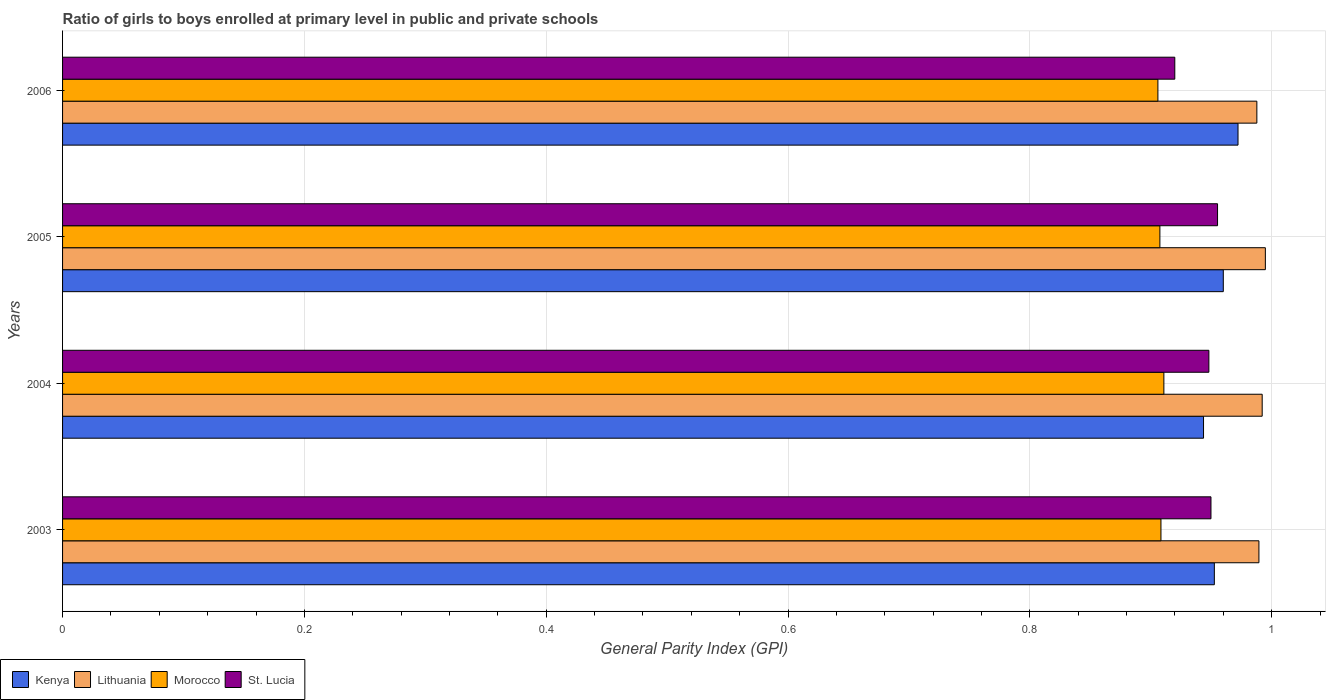How many groups of bars are there?
Provide a short and direct response. 4. Are the number of bars per tick equal to the number of legend labels?
Offer a terse response. Yes. What is the general parity index in St. Lucia in 2004?
Ensure brevity in your answer.  0.95. Across all years, what is the maximum general parity index in Kenya?
Your response must be concise. 0.97. Across all years, what is the minimum general parity index in Lithuania?
Your answer should be very brief. 0.99. What is the total general parity index in Kenya in the graph?
Your answer should be very brief. 3.83. What is the difference between the general parity index in Lithuania in 2003 and that in 2006?
Your answer should be compact. 0. What is the difference between the general parity index in St. Lucia in 2004 and the general parity index in Kenya in 2005?
Offer a very short reply. -0.01. What is the average general parity index in Morocco per year?
Ensure brevity in your answer.  0.91. In the year 2005, what is the difference between the general parity index in St. Lucia and general parity index in Lithuania?
Provide a short and direct response. -0.04. In how many years, is the general parity index in St. Lucia greater than 0.16 ?
Your answer should be compact. 4. What is the ratio of the general parity index in Kenya in 2004 to that in 2005?
Your answer should be very brief. 0.98. Is the difference between the general parity index in St. Lucia in 2004 and 2006 greater than the difference between the general parity index in Lithuania in 2004 and 2006?
Offer a terse response. Yes. What is the difference between the highest and the second highest general parity index in Lithuania?
Ensure brevity in your answer.  0. What is the difference between the highest and the lowest general parity index in Kenya?
Ensure brevity in your answer.  0.03. In how many years, is the general parity index in St. Lucia greater than the average general parity index in St. Lucia taken over all years?
Your response must be concise. 3. Is the sum of the general parity index in St. Lucia in 2003 and 2006 greater than the maximum general parity index in Lithuania across all years?
Your answer should be very brief. Yes. Is it the case that in every year, the sum of the general parity index in Kenya and general parity index in Lithuania is greater than the sum of general parity index in Morocco and general parity index in St. Lucia?
Provide a short and direct response. No. What does the 2nd bar from the top in 2003 represents?
Offer a very short reply. Morocco. What does the 2nd bar from the bottom in 2003 represents?
Offer a very short reply. Lithuania. How many bars are there?
Keep it short and to the point. 16. What is the difference between two consecutive major ticks on the X-axis?
Make the answer very short. 0.2. Are the values on the major ticks of X-axis written in scientific E-notation?
Keep it short and to the point. No. Does the graph contain grids?
Your answer should be very brief. Yes. Where does the legend appear in the graph?
Ensure brevity in your answer.  Bottom left. How many legend labels are there?
Offer a very short reply. 4. How are the legend labels stacked?
Make the answer very short. Horizontal. What is the title of the graph?
Make the answer very short. Ratio of girls to boys enrolled at primary level in public and private schools. What is the label or title of the X-axis?
Offer a very short reply. General Parity Index (GPI). What is the General Parity Index (GPI) in Kenya in 2003?
Provide a short and direct response. 0.95. What is the General Parity Index (GPI) in Lithuania in 2003?
Provide a short and direct response. 0.99. What is the General Parity Index (GPI) of Morocco in 2003?
Your response must be concise. 0.91. What is the General Parity Index (GPI) in St. Lucia in 2003?
Keep it short and to the point. 0.95. What is the General Parity Index (GPI) in Kenya in 2004?
Your answer should be very brief. 0.94. What is the General Parity Index (GPI) in Lithuania in 2004?
Ensure brevity in your answer.  0.99. What is the General Parity Index (GPI) of Morocco in 2004?
Give a very brief answer. 0.91. What is the General Parity Index (GPI) of St. Lucia in 2004?
Your response must be concise. 0.95. What is the General Parity Index (GPI) of Kenya in 2005?
Provide a short and direct response. 0.96. What is the General Parity Index (GPI) in Lithuania in 2005?
Make the answer very short. 0.99. What is the General Parity Index (GPI) of Morocco in 2005?
Provide a succinct answer. 0.91. What is the General Parity Index (GPI) of St. Lucia in 2005?
Offer a very short reply. 0.96. What is the General Parity Index (GPI) of Kenya in 2006?
Make the answer very short. 0.97. What is the General Parity Index (GPI) in Lithuania in 2006?
Offer a very short reply. 0.99. What is the General Parity Index (GPI) of Morocco in 2006?
Ensure brevity in your answer.  0.91. What is the General Parity Index (GPI) in St. Lucia in 2006?
Your answer should be very brief. 0.92. Across all years, what is the maximum General Parity Index (GPI) in Kenya?
Keep it short and to the point. 0.97. Across all years, what is the maximum General Parity Index (GPI) in Lithuania?
Ensure brevity in your answer.  0.99. Across all years, what is the maximum General Parity Index (GPI) of Morocco?
Your answer should be compact. 0.91. Across all years, what is the maximum General Parity Index (GPI) in St. Lucia?
Offer a very short reply. 0.96. Across all years, what is the minimum General Parity Index (GPI) of Kenya?
Keep it short and to the point. 0.94. Across all years, what is the minimum General Parity Index (GPI) in Lithuania?
Offer a very short reply. 0.99. Across all years, what is the minimum General Parity Index (GPI) in Morocco?
Provide a succinct answer. 0.91. Across all years, what is the minimum General Parity Index (GPI) in St. Lucia?
Your answer should be very brief. 0.92. What is the total General Parity Index (GPI) in Kenya in the graph?
Make the answer very short. 3.83. What is the total General Parity Index (GPI) of Lithuania in the graph?
Your answer should be very brief. 3.96. What is the total General Parity Index (GPI) of Morocco in the graph?
Ensure brevity in your answer.  3.63. What is the total General Parity Index (GPI) of St. Lucia in the graph?
Offer a terse response. 3.77. What is the difference between the General Parity Index (GPI) in Kenya in 2003 and that in 2004?
Offer a very short reply. 0.01. What is the difference between the General Parity Index (GPI) in Lithuania in 2003 and that in 2004?
Your response must be concise. -0. What is the difference between the General Parity Index (GPI) in Morocco in 2003 and that in 2004?
Make the answer very short. -0. What is the difference between the General Parity Index (GPI) in St. Lucia in 2003 and that in 2004?
Offer a very short reply. 0. What is the difference between the General Parity Index (GPI) in Kenya in 2003 and that in 2005?
Your answer should be compact. -0.01. What is the difference between the General Parity Index (GPI) of Lithuania in 2003 and that in 2005?
Your response must be concise. -0.01. What is the difference between the General Parity Index (GPI) of Morocco in 2003 and that in 2005?
Keep it short and to the point. 0. What is the difference between the General Parity Index (GPI) of St. Lucia in 2003 and that in 2005?
Ensure brevity in your answer.  -0.01. What is the difference between the General Parity Index (GPI) in Kenya in 2003 and that in 2006?
Your answer should be very brief. -0.02. What is the difference between the General Parity Index (GPI) of Lithuania in 2003 and that in 2006?
Offer a terse response. 0. What is the difference between the General Parity Index (GPI) in Morocco in 2003 and that in 2006?
Your response must be concise. 0. What is the difference between the General Parity Index (GPI) of St. Lucia in 2003 and that in 2006?
Keep it short and to the point. 0.03. What is the difference between the General Parity Index (GPI) in Kenya in 2004 and that in 2005?
Your response must be concise. -0.02. What is the difference between the General Parity Index (GPI) of Lithuania in 2004 and that in 2005?
Offer a very short reply. -0. What is the difference between the General Parity Index (GPI) of Morocco in 2004 and that in 2005?
Make the answer very short. 0. What is the difference between the General Parity Index (GPI) of St. Lucia in 2004 and that in 2005?
Provide a succinct answer. -0.01. What is the difference between the General Parity Index (GPI) in Kenya in 2004 and that in 2006?
Your answer should be compact. -0.03. What is the difference between the General Parity Index (GPI) in Lithuania in 2004 and that in 2006?
Ensure brevity in your answer.  0. What is the difference between the General Parity Index (GPI) of Morocco in 2004 and that in 2006?
Your answer should be very brief. 0. What is the difference between the General Parity Index (GPI) in St. Lucia in 2004 and that in 2006?
Your answer should be very brief. 0.03. What is the difference between the General Parity Index (GPI) in Kenya in 2005 and that in 2006?
Your response must be concise. -0.01. What is the difference between the General Parity Index (GPI) of Lithuania in 2005 and that in 2006?
Keep it short and to the point. 0.01. What is the difference between the General Parity Index (GPI) in Morocco in 2005 and that in 2006?
Provide a succinct answer. 0. What is the difference between the General Parity Index (GPI) in St. Lucia in 2005 and that in 2006?
Ensure brevity in your answer.  0.04. What is the difference between the General Parity Index (GPI) of Kenya in 2003 and the General Parity Index (GPI) of Lithuania in 2004?
Provide a succinct answer. -0.04. What is the difference between the General Parity Index (GPI) of Kenya in 2003 and the General Parity Index (GPI) of Morocco in 2004?
Your answer should be compact. 0.04. What is the difference between the General Parity Index (GPI) of Kenya in 2003 and the General Parity Index (GPI) of St. Lucia in 2004?
Your answer should be compact. 0. What is the difference between the General Parity Index (GPI) of Lithuania in 2003 and the General Parity Index (GPI) of Morocco in 2004?
Keep it short and to the point. 0.08. What is the difference between the General Parity Index (GPI) of Lithuania in 2003 and the General Parity Index (GPI) of St. Lucia in 2004?
Keep it short and to the point. 0.04. What is the difference between the General Parity Index (GPI) in Morocco in 2003 and the General Parity Index (GPI) in St. Lucia in 2004?
Your answer should be compact. -0.04. What is the difference between the General Parity Index (GPI) in Kenya in 2003 and the General Parity Index (GPI) in Lithuania in 2005?
Keep it short and to the point. -0.04. What is the difference between the General Parity Index (GPI) of Kenya in 2003 and the General Parity Index (GPI) of Morocco in 2005?
Provide a short and direct response. 0.04. What is the difference between the General Parity Index (GPI) in Kenya in 2003 and the General Parity Index (GPI) in St. Lucia in 2005?
Your response must be concise. -0. What is the difference between the General Parity Index (GPI) in Lithuania in 2003 and the General Parity Index (GPI) in Morocco in 2005?
Keep it short and to the point. 0.08. What is the difference between the General Parity Index (GPI) in Lithuania in 2003 and the General Parity Index (GPI) in St. Lucia in 2005?
Provide a succinct answer. 0.03. What is the difference between the General Parity Index (GPI) in Morocco in 2003 and the General Parity Index (GPI) in St. Lucia in 2005?
Your answer should be compact. -0.05. What is the difference between the General Parity Index (GPI) in Kenya in 2003 and the General Parity Index (GPI) in Lithuania in 2006?
Your answer should be compact. -0.04. What is the difference between the General Parity Index (GPI) in Kenya in 2003 and the General Parity Index (GPI) in Morocco in 2006?
Your answer should be very brief. 0.05. What is the difference between the General Parity Index (GPI) in Kenya in 2003 and the General Parity Index (GPI) in St. Lucia in 2006?
Your response must be concise. 0.03. What is the difference between the General Parity Index (GPI) of Lithuania in 2003 and the General Parity Index (GPI) of Morocco in 2006?
Offer a terse response. 0.08. What is the difference between the General Parity Index (GPI) in Lithuania in 2003 and the General Parity Index (GPI) in St. Lucia in 2006?
Offer a very short reply. 0.07. What is the difference between the General Parity Index (GPI) in Morocco in 2003 and the General Parity Index (GPI) in St. Lucia in 2006?
Your response must be concise. -0.01. What is the difference between the General Parity Index (GPI) of Kenya in 2004 and the General Parity Index (GPI) of Lithuania in 2005?
Give a very brief answer. -0.05. What is the difference between the General Parity Index (GPI) in Kenya in 2004 and the General Parity Index (GPI) in Morocco in 2005?
Offer a terse response. 0.04. What is the difference between the General Parity Index (GPI) of Kenya in 2004 and the General Parity Index (GPI) of St. Lucia in 2005?
Your answer should be compact. -0.01. What is the difference between the General Parity Index (GPI) in Lithuania in 2004 and the General Parity Index (GPI) in Morocco in 2005?
Provide a short and direct response. 0.08. What is the difference between the General Parity Index (GPI) of Lithuania in 2004 and the General Parity Index (GPI) of St. Lucia in 2005?
Offer a very short reply. 0.04. What is the difference between the General Parity Index (GPI) in Morocco in 2004 and the General Parity Index (GPI) in St. Lucia in 2005?
Your answer should be very brief. -0.04. What is the difference between the General Parity Index (GPI) in Kenya in 2004 and the General Parity Index (GPI) in Lithuania in 2006?
Your answer should be compact. -0.04. What is the difference between the General Parity Index (GPI) in Kenya in 2004 and the General Parity Index (GPI) in Morocco in 2006?
Offer a very short reply. 0.04. What is the difference between the General Parity Index (GPI) of Kenya in 2004 and the General Parity Index (GPI) of St. Lucia in 2006?
Your response must be concise. 0.02. What is the difference between the General Parity Index (GPI) in Lithuania in 2004 and the General Parity Index (GPI) in Morocco in 2006?
Your response must be concise. 0.09. What is the difference between the General Parity Index (GPI) of Lithuania in 2004 and the General Parity Index (GPI) of St. Lucia in 2006?
Your answer should be very brief. 0.07. What is the difference between the General Parity Index (GPI) of Morocco in 2004 and the General Parity Index (GPI) of St. Lucia in 2006?
Provide a short and direct response. -0.01. What is the difference between the General Parity Index (GPI) of Kenya in 2005 and the General Parity Index (GPI) of Lithuania in 2006?
Give a very brief answer. -0.03. What is the difference between the General Parity Index (GPI) of Kenya in 2005 and the General Parity Index (GPI) of Morocco in 2006?
Ensure brevity in your answer.  0.05. What is the difference between the General Parity Index (GPI) of Kenya in 2005 and the General Parity Index (GPI) of St. Lucia in 2006?
Your answer should be very brief. 0.04. What is the difference between the General Parity Index (GPI) in Lithuania in 2005 and the General Parity Index (GPI) in Morocco in 2006?
Your answer should be very brief. 0.09. What is the difference between the General Parity Index (GPI) in Lithuania in 2005 and the General Parity Index (GPI) in St. Lucia in 2006?
Your answer should be very brief. 0.07. What is the difference between the General Parity Index (GPI) of Morocco in 2005 and the General Parity Index (GPI) of St. Lucia in 2006?
Make the answer very short. -0.01. What is the average General Parity Index (GPI) of Kenya per year?
Your answer should be very brief. 0.96. What is the average General Parity Index (GPI) of Morocco per year?
Offer a terse response. 0.91. What is the average General Parity Index (GPI) in St. Lucia per year?
Ensure brevity in your answer.  0.94. In the year 2003, what is the difference between the General Parity Index (GPI) in Kenya and General Parity Index (GPI) in Lithuania?
Your response must be concise. -0.04. In the year 2003, what is the difference between the General Parity Index (GPI) in Kenya and General Parity Index (GPI) in Morocco?
Offer a terse response. 0.04. In the year 2003, what is the difference between the General Parity Index (GPI) of Kenya and General Parity Index (GPI) of St. Lucia?
Provide a short and direct response. 0. In the year 2003, what is the difference between the General Parity Index (GPI) in Lithuania and General Parity Index (GPI) in Morocco?
Provide a short and direct response. 0.08. In the year 2003, what is the difference between the General Parity Index (GPI) of Lithuania and General Parity Index (GPI) of St. Lucia?
Keep it short and to the point. 0.04. In the year 2003, what is the difference between the General Parity Index (GPI) in Morocco and General Parity Index (GPI) in St. Lucia?
Provide a short and direct response. -0.04. In the year 2004, what is the difference between the General Parity Index (GPI) in Kenya and General Parity Index (GPI) in Lithuania?
Make the answer very short. -0.05. In the year 2004, what is the difference between the General Parity Index (GPI) of Kenya and General Parity Index (GPI) of Morocco?
Keep it short and to the point. 0.03. In the year 2004, what is the difference between the General Parity Index (GPI) of Kenya and General Parity Index (GPI) of St. Lucia?
Your answer should be very brief. -0. In the year 2004, what is the difference between the General Parity Index (GPI) in Lithuania and General Parity Index (GPI) in Morocco?
Ensure brevity in your answer.  0.08. In the year 2004, what is the difference between the General Parity Index (GPI) of Lithuania and General Parity Index (GPI) of St. Lucia?
Give a very brief answer. 0.04. In the year 2004, what is the difference between the General Parity Index (GPI) in Morocco and General Parity Index (GPI) in St. Lucia?
Your answer should be very brief. -0.04. In the year 2005, what is the difference between the General Parity Index (GPI) of Kenya and General Parity Index (GPI) of Lithuania?
Provide a succinct answer. -0.03. In the year 2005, what is the difference between the General Parity Index (GPI) in Kenya and General Parity Index (GPI) in Morocco?
Provide a short and direct response. 0.05. In the year 2005, what is the difference between the General Parity Index (GPI) of Kenya and General Parity Index (GPI) of St. Lucia?
Make the answer very short. 0. In the year 2005, what is the difference between the General Parity Index (GPI) of Lithuania and General Parity Index (GPI) of Morocco?
Offer a very short reply. 0.09. In the year 2005, what is the difference between the General Parity Index (GPI) in Lithuania and General Parity Index (GPI) in St. Lucia?
Your answer should be compact. 0.04. In the year 2005, what is the difference between the General Parity Index (GPI) of Morocco and General Parity Index (GPI) of St. Lucia?
Give a very brief answer. -0.05. In the year 2006, what is the difference between the General Parity Index (GPI) of Kenya and General Parity Index (GPI) of Lithuania?
Your response must be concise. -0.02. In the year 2006, what is the difference between the General Parity Index (GPI) in Kenya and General Parity Index (GPI) in Morocco?
Provide a short and direct response. 0.07. In the year 2006, what is the difference between the General Parity Index (GPI) in Kenya and General Parity Index (GPI) in St. Lucia?
Offer a terse response. 0.05. In the year 2006, what is the difference between the General Parity Index (GPI) of Lithuania and General Parity Index (GPI) of Morocco?
Offer a terse response. 0.08. In the year 2006, what is the difference between the General Parity Index (GPI) of Lithuania and General Parity Index (GPI) of St. Lucia?
Keep it short and to the point. 0.07. In the year 2006, what is the difference between the General Parity Index (GPI) of Morocco and General Parity Index (GPI) of St. Lucia?
Your response must be concise. -0.01. What is the ratio of the General Parity Index (GPI) in Kenya in 2003 to that in 2004?
Offer a very short reply. 1.01. What is the ratio of the General Parity Index (GPI) in Morocco in 2003 to that in 2004?
Your response must be concise. 1. What is the ratio of the General Parity Index (GPI) in St. Lucia in 2003 to that in 2004?
Ensure brevity in your answer.  1. What is the ratio of the General Parity Index (GPI) of Kenya in 2003 to that in 2005?
Your answer should be very brief. 0.99. What is the ratio of the General Parity Index (GPI) of Lithuania in 2003 to that in 2005?
Offer a terse response. 0.99. What is the ratio of the General Parity Index (GPI) in Morocco in 2003 to that in 2005?
Offer a terse response. 1. What is the ratio of the General Parity Index (GPI) in St. Lucia in 2003 to that in 2005?
Ensure brevity in your answer.  0.99. What is the ratio of the General Parity Index (GPI) in Kenya in 2003 to that in 2006?
Your response must be concise. 0.98. What is the ratio of the General Parity Index (GPI) of St. Lucia in 2003 to that in 2006?
Give a very brief answer. 1.03. What is the ratio of the General Parity Index (GPI) in Lithuania in 2004 to that in 2005?
Your answer should be compact. 1. What is the ratio of the General Parity Index (GPI) in Kenya in 2004 to that in 2006?
Your answer should be compact. 0.97. What is the ratio of the General Parity Index (GPI) of St. Lucia in 2004 to that in 2006?
Ensure brevity in your answer.  1.03. What is the ratio of the General Parity Index (GPI) in Kenya in 2005 to that in 2006?
Offer a very short reply. 0.99. What is the ratio of the General Parity Index (GPI) of Lithuania in 2005 to that in 2006?
Offer a very short reply. 1.01. What is the ratio of the General Parity Index (GPI) of Morocco in 2005 to that in 2006?
Your response must be concise. 1. What is the ratio of the General Parity Index (GPI) of St. Lucia in 2005 to that in 2006?
Provide a succinct answer. 1.04. What is the difference between the highest and the second highest General Parity Index (GPI) in Kenya?
Give a very brief answer. 0.01. What is the difference between the highest and the second highest General Parity Index (GPI) in Lithuania?
Give a very brief answer. 0. What is the difference between the highest and the second highest General Parity Index (GPI) of Morocco?
Ensure brevity in your answer.  0. What is the difference between the highest and the second highest General Parity Index (GPI) of St. Lucia?
Your answer should be compact. 0.01. What is the difference between the highest and the lowest General Parity Index (GPI) of Kenya?
Your answer should be compact. 0.03. What is the difference between the highest and the lowest General Parity Index (GPI) in Lithuania?
Provide a short and direct response. 0.01. What is the difference between the highest and the lowest General Parity Index (GPI) of Morocco?
Give a very brief answer. 0. What is the difference between the highest and the lowest General Parity Index (GPI) in St. Lucia?
Give a very brief answer. 0.04. 